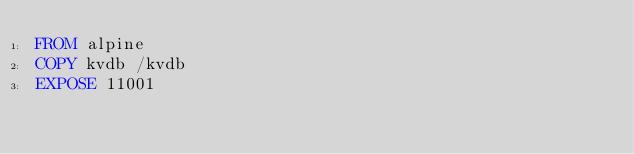Convert code to text. <code><loc_0><loc_0><loc_500><loc_500><_Dockerfile_>FROM alpine
COPY kvdb /kvdb
EXPOSE 11001
</code> 